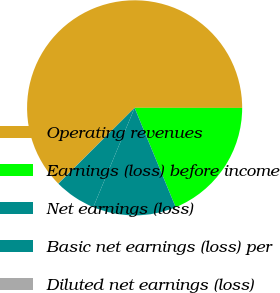Convert chart to OTSL. <chart><loc_0><loc_0><loc_500><loc_500><pie_chart><fcel>Operating revenues<fcel>Earnings (loss) before income<fcel>Net earnings (loss)<fcel>Basic net earnings (loss) per<fcel>Diluted net earnings (loss)<nl><fcel>62.45%<fcel>18.75%<fcel>12.51%<fcel>6.27%<fcel>0.02%<nl></chart> 